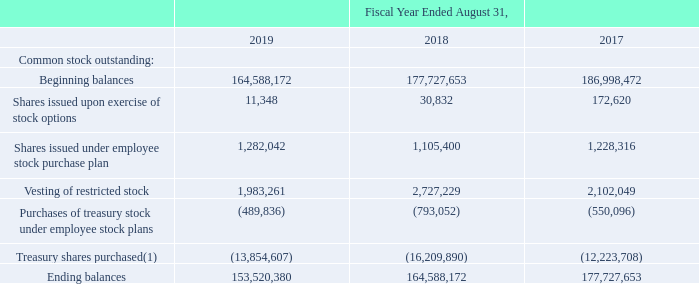Common Stock Outstanding
The following represents the common stock outstanding for the fiscal year ended:
(1) During fiscal years 2018, 2017 and 2016, the Company’s Board of Directors authorized the repurchase of $350.0 million, $450.0 million and $400.0 million, respectively, of the Company’s common stock under share repurchase programs, which were repurchased during fiscal years 2019, 2018 and 2017, respectively.
What years does the table provide information for the common stock outstanding for? 2019, 2018, 2017. What was the Beginning balance in 2019? 164,588,172. What was the Ending balance in 2017? 177,727,653. What was the change in the Vesting of restricted stock between 2018 and 2019? 1,983,261-2,727,229
Answer: -743968. How many years did the Shares issued upon exercise of stock options exceed 100,000? 2017
Answer: 1. What was the percentage change in the ending balance between 2018 and 2019?
Answer scale should be: percent. (153,520,380-164,588,172)/164,588,172
Answer: -6.72. 